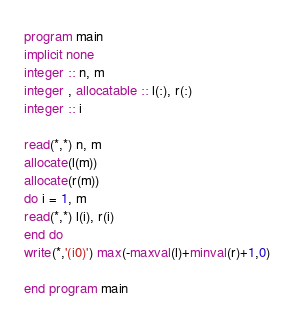<code> <loc_0><loc_0><loc_500><loc_500><_FORTRAN_>program main
implicit none
integer :: n, m
integer , allocatable :: l(:), r(:)
integer :: i

read(*,*) n, m
allocate(l(m))
allocate(r(m))
do i = 1, m
read(*,*) l(i), r(i)
end do
write(*,'(i0)') max(-maxval(l)+minval(r)+1,0)

end program main
</code> 